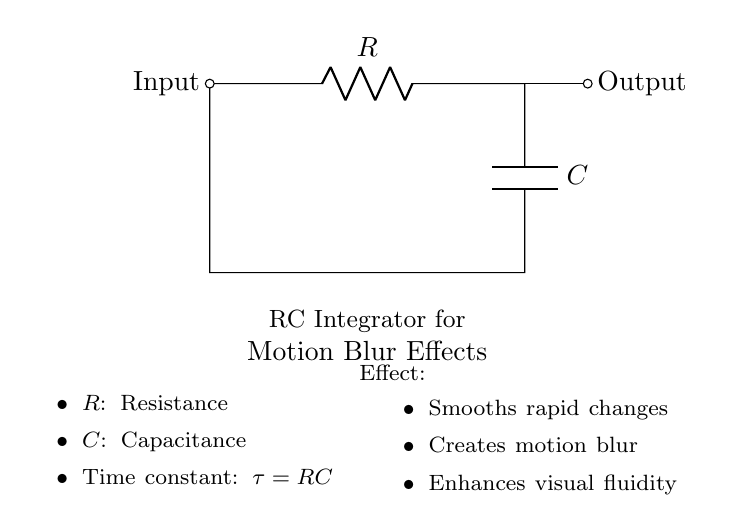What components are present in this circuit? The circuit diagram shows a resistor and a capacitor, labeled as R and C, respectively. Therefore, the components present are R and C.
Answer: Resistor and Capacitor What is the time constant of the RC circuit? The time constant is calculated using the formula τ = RC, where R is the resistance and C is the capacitance. The diagram implies this relationship.
Answer: RC What role does the resistor play in the circuit? In an RC integrator, the resistor controls the charging and discharging rate of the capacitor, impacting the integration effect it provides.
Answer: Controls charging rate What is the primary effect of this RC integrator? The circuit is designed to smooth rapid changes and create motion blur effects in visuals. This is indicated in the description within the circuit diagram.
Answer: Motion blur How does the capacitor affect the output signal? The capacitor in the integrator circuit integrates the input signal over time, which smooths out rapid changes and produces a more fluid output. This is a key characteristic of its function as shown in the circuit.
Answer: Smoothens the output What happens to the output when rapid changes occur at the input? When there are rapid changes at the input, the capacitor slowly charges and discharges, causing the output to lag behind and creating a motion blur effect. This behavior is typical for RC integrators.
Answer: Lagging output 